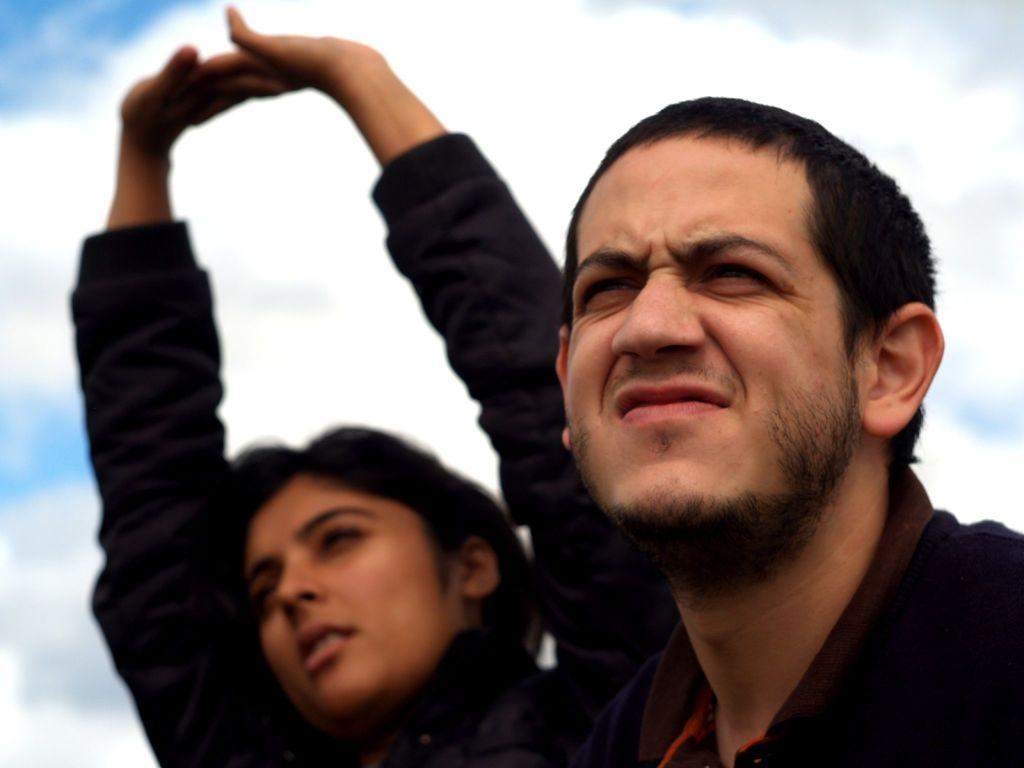How many people are in the image? There are two persons in the image. What are the persons wearing? The persons are wearing dresses. What can be seen in the background of the image? There is a cloudy sky in the background of the image. Are there any icicles hanging from the persons' dresses in the image? No, there are no icicles present in the image. What type of insect can be seen flying around the persons in the image? There are no insects visible in the image. 